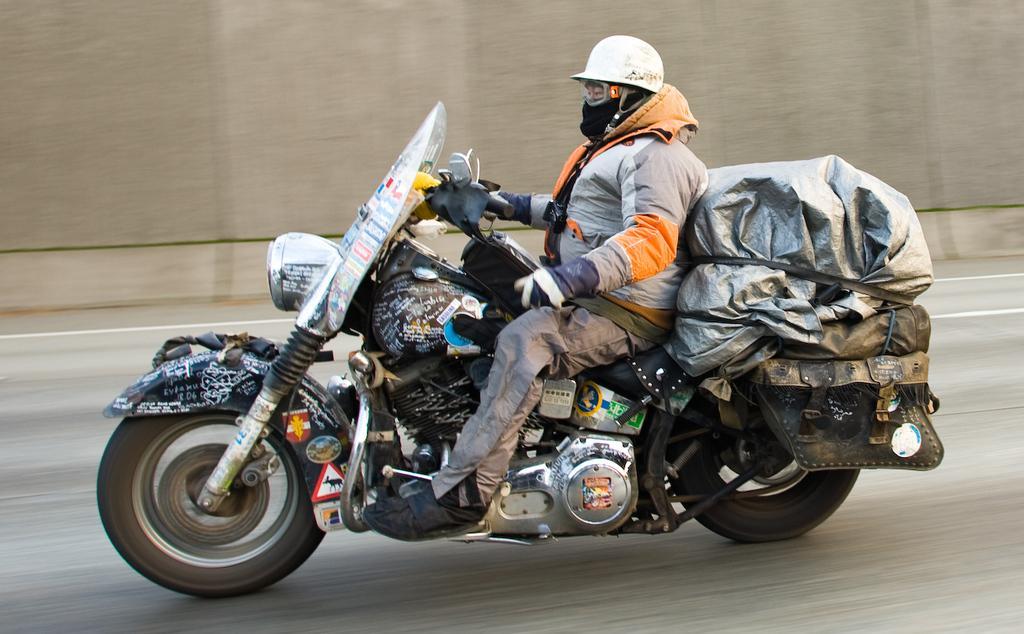Please provide a concise description of this image. This is the picture of a man riding a bike, on the bike there are some items. The man is riding a bike on road. 